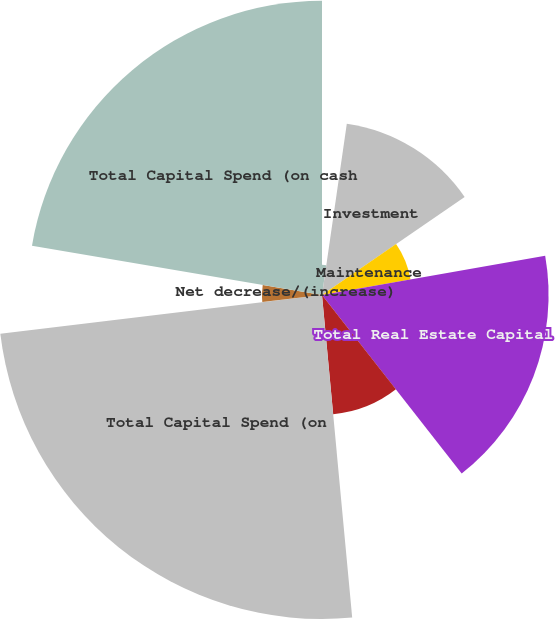<chart> <loc_0><loc_0><loc_500><loc_500><pie_chart><fcel>Nature of Capital Spend (in<fcel>Investment<fcel>Maintenance<fcel>Total Real Estate Capital<fcel>Total Non-Real Estate Capital<fcel>Total Capital Spend (on<fcel>Net (decrease)/increase in<fcel>Net decrease/(increase)<fcel>Total Capital Spend (on cash<nl><fcel>2.29%<fcel>13.13%<fcel>6.82%<fcel>17.19%<fcel>9.09%<fcel>24.58%<fcel>0.03%<fcel>4.56%<fcel>22.32%<nl></chart> 